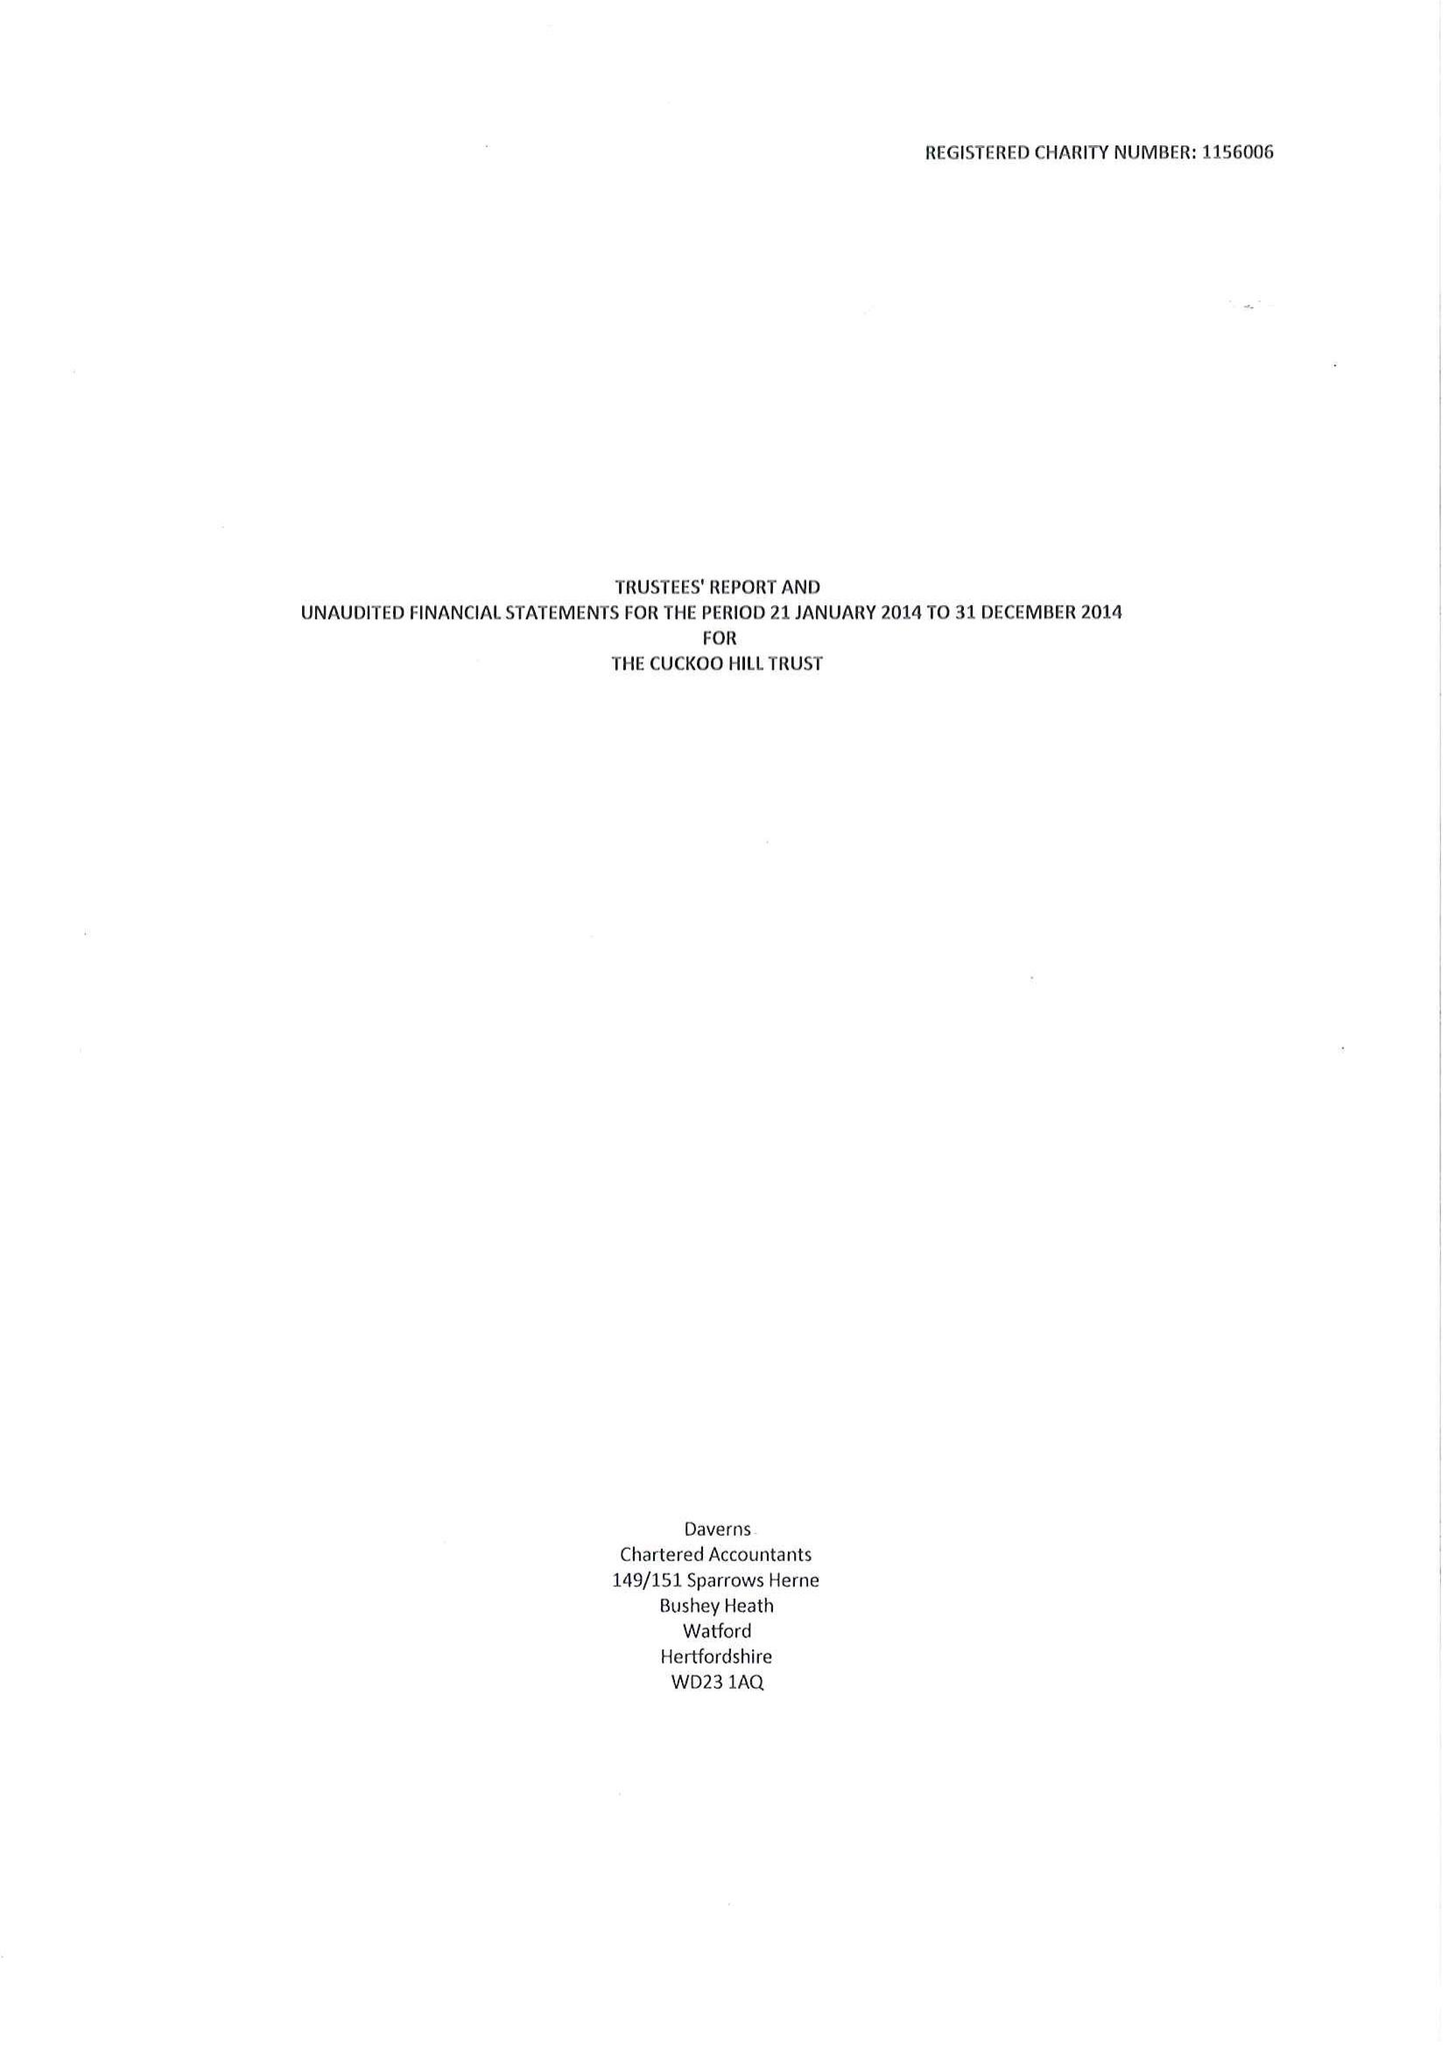What is the value for the report_date?
Answer the question using a single word or phrase. 2014-12-31 